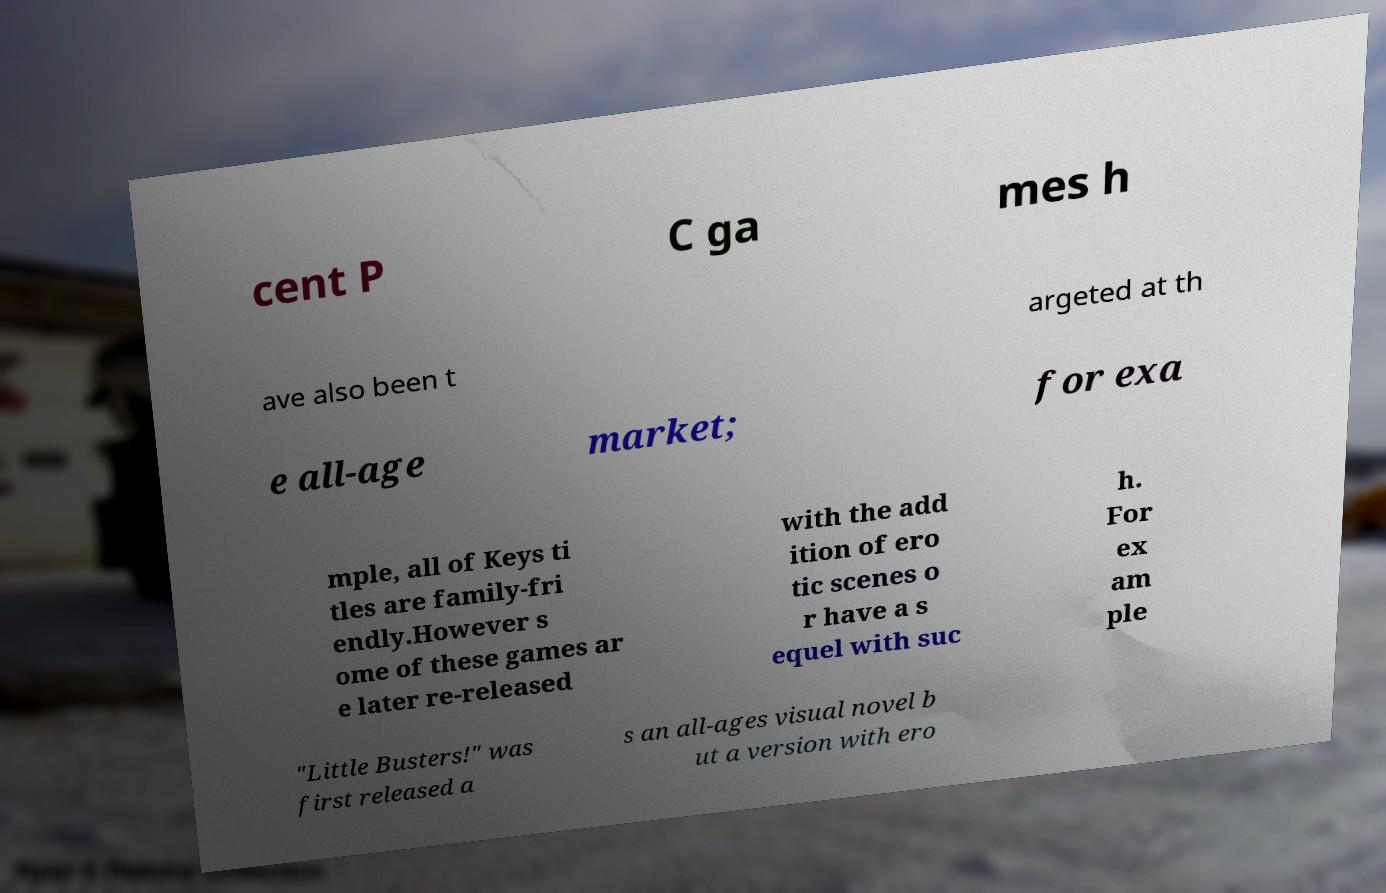I need the written content from this picture converted into text. Can you do that? cent P C ga mes h ave also been t argeted at th e all-age market; for exa mple, all of Keys ti tles are family-fri endly.However s ome of these games ar e later re-released with the add ition of ero tic scenes o r have a s equel with suc h. For ex am ple "Little Busters!" was first released a s an all-ages visual novel b ut a version with ero 